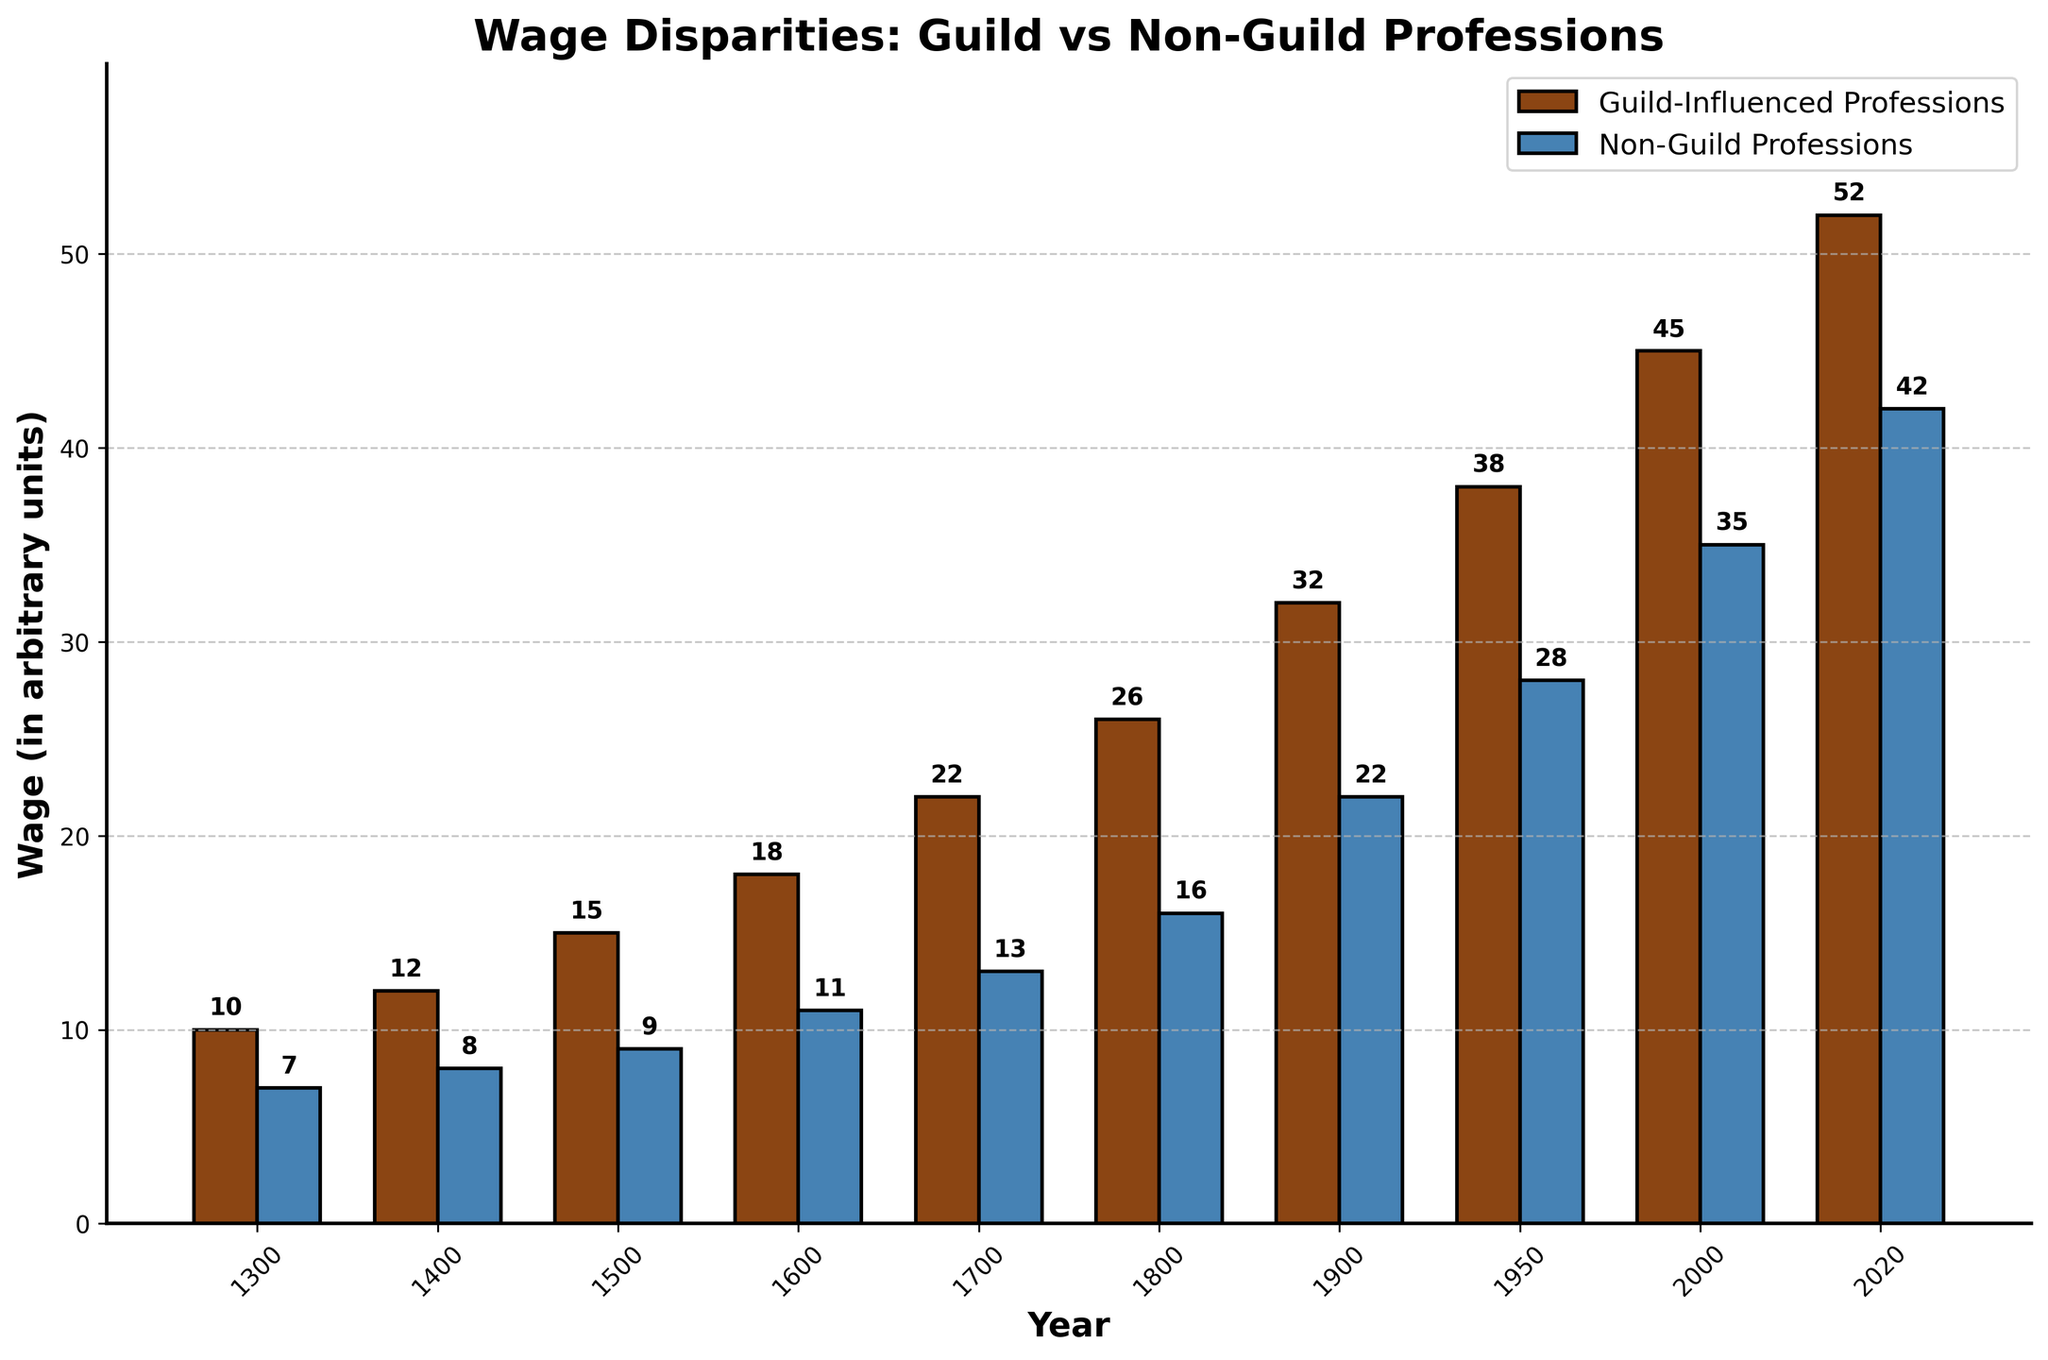What is the wage disparity between Guild-Influenced Professions and Non-Guild Professions in 1700? Find the values for 1700: Guild-Influenced Professions = 22 and Non-Guild Professions = 13. Subtract the latter from the former: 22 - 13 = 9
Answer: 9 Which year had the smallest wage gap between Guild-Influenced Professions and Non-Guild Professions? Calculate the wage disparity for each year and identify the smallest: 1300 → 10-7=3, 1400 → 12-8=4, 1500 → 15-9=6, 1600 → 18-11=7, 1700 → 22-13=9, 1800 → 26-16=10, 1900 → 32-22=10, 1950 → 38-28=10, 2000 → 45-35=10, 2020 → 52-42=10. The smallest gap is 3 in 1300
Answer: 1300 What is the overall trend in wages for Guild-Influenced Professions from 1300 to 2020? Observe the heights of the bars representing Guild-Influenced Professions for each year. The height increases steadily from 10 in 1300 to 52 in 2020, indicating an upward trend
Answer: Upward trend In what year did Guild-Influenced Professions first reach a wage value of 30 or more? Identify the first year where the bar for Guild-Influenced Professions reaches or exceeds 30: 1900 has a wage of 32, which is the first instance
Answer: 1900 By how much did the wage in Non-Guild Professions increase from 1400 to 2000? Find the values for 1400 (8) and 2000 (35). Subtract the former from the latter: 35 - 8 = 27
Answer: 27 Which year shows the maximum wage value for Non-Guild Professions? Identify the highest bar for Non-Guild Professions: The year 2020 has the highest value at 42
Answer: 2020 Compare the average wages of Guild-Influenced Professions and Non-Guild Professions over all the years presented. Calculate the average for each: Guild-Influenced Professions = (10+12+15+18+22+26+32+38+45+52)/10 = 27, Non-Guild Professions = (7+8+9+11+13+16+22+28+35+42)/10 = 19.1
Answer: Guild-Influenced: 27, Non-Guild: 19.1 What is the visual difference between the bars of Guild-Influenced Professions and Non-Guild Professions? Discuss the bar colors (brown for Guild-Influenced, blue for Non-Guild), their widths, heights, and the presence of edge colors: Brown bars representing Guild-Influenced Professions are generally taller compared to blue bars representing Non-Guild Professions
Answer: Brown bars are generally taller than blue bars Which period saw the largest increase in wages for Guild-Influenced Professions? Determine the increase in wages for each consecutive period and identify the largest increase: 1300-1400→2, 1400-1500→3, 1500-1600→3, 1600-1700→4, 1700-1800→4, 1800-1900→6, 1900-1950→6, 1950-2000→7, 2000-2020→7. The largest increases are from 1950-2000 and 2000-2020
Answer: 1950-2000 and 2000-2020 How did the wage of Non-Guild Professions change between 1900 and 1950? Find the values for 1900 (22) and 1950 (28). Subtract the former from the latter: 28 - 22 = 6
Answer: 6 